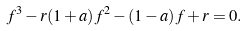<formula> <loc_0><loc_0><loc_500><loc_500>f ^ { 3 } - r ( 1 + a ) f ^ { 2 } - ( 1 - a ) f + r = 0 .</formula> 